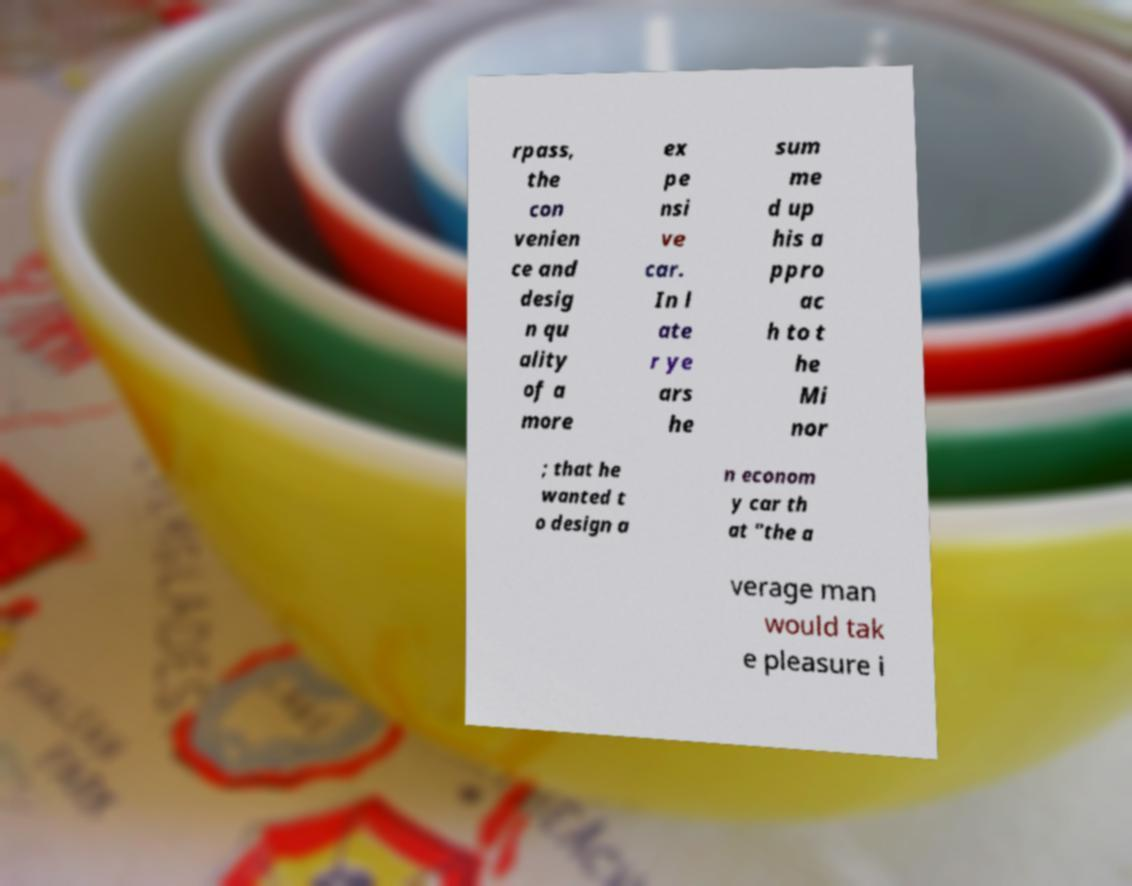What messages or text are displayed in this image? I need them in a readable, typed format. rpass, the con venien ce and desig n qu ality of a more ex pe nsi ve car. In l ate r ye ars he sum me d up his a ppro ac h to t he Mi nor ; that he wanted t o design a n econom y car th at "the a verage man would tak e pleasure i 